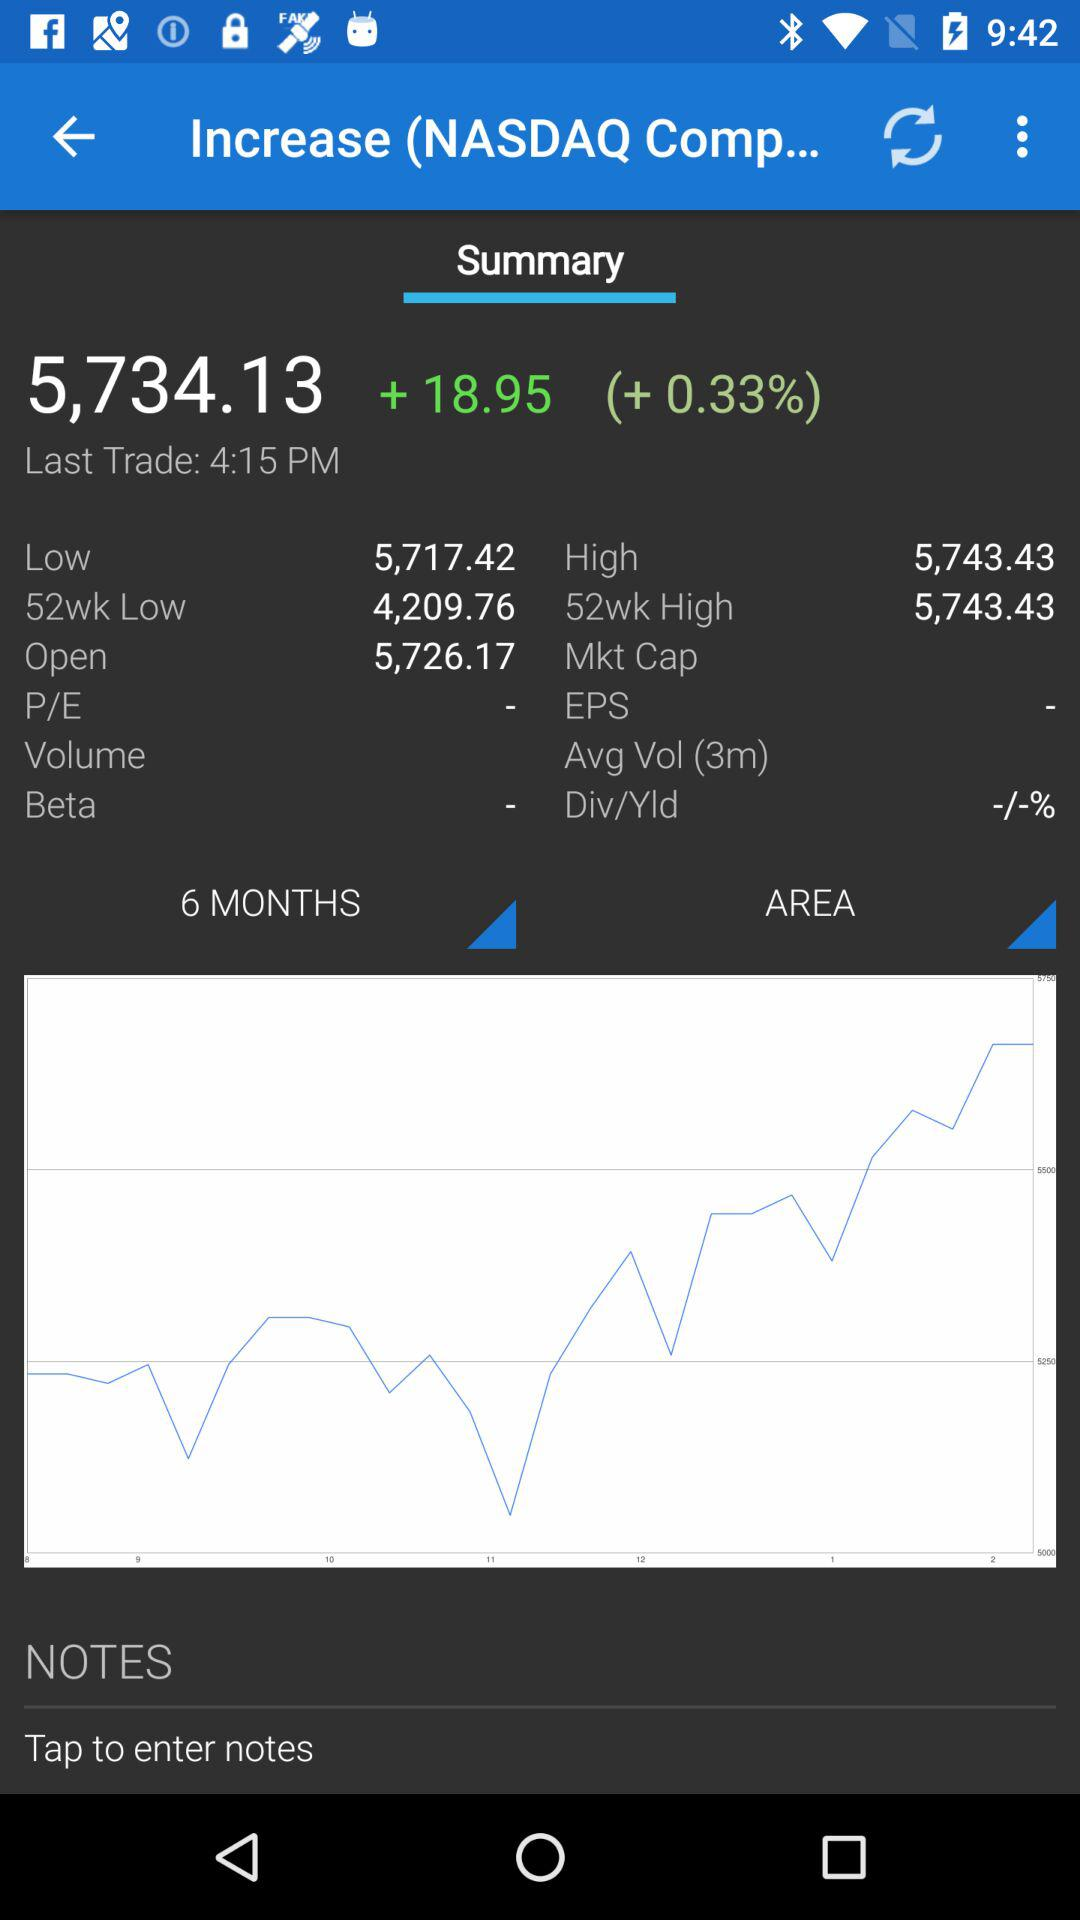What is the value of "52wk Low"? The value is 4,209.76. 